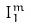Convert formula to latex. <formula><loc_0><loc_0><loc_500><loc_500>I _ { 1 } ^ { m }</formula> 